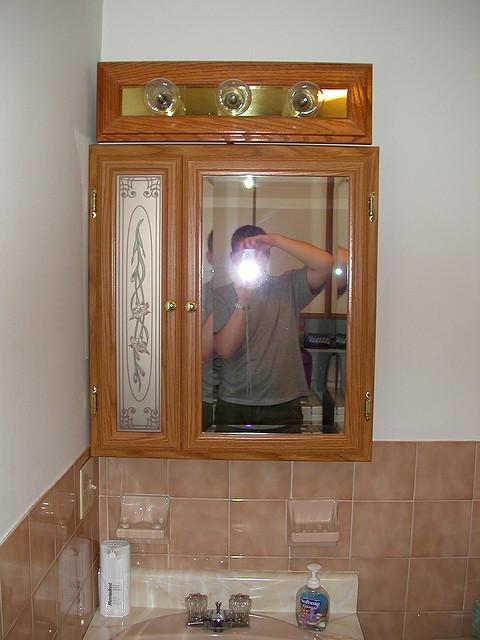Is the photographer using a flash?
Be succinct. Yes. What brand of soap is on the sink?
Concise answer only. Softsoap. What color is the tile on the wall?
Write a very short answer. Brown. 